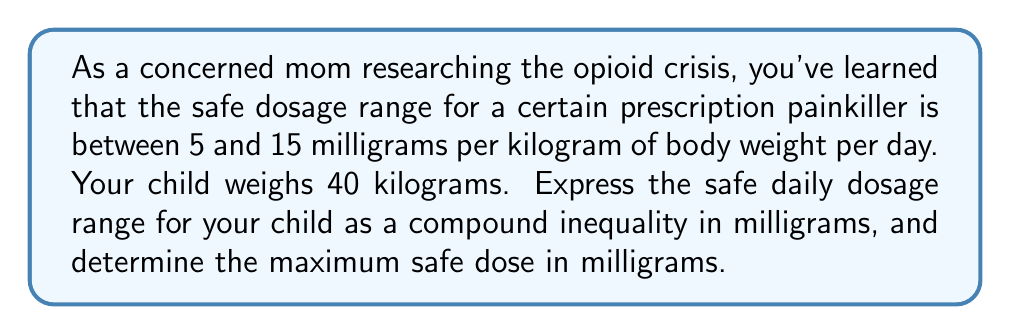Could you help me with this problem? Let's approach this step-by-step:

1) The safe dosage range is 5 to 15 mg per kg of body weight per day.
2) Your child weighs 40 kg.

To find the safe dosage range for your child, we need to multiply both the lower and upper limits by 40:

Lower limit: $5 \times 40 = 200$ mg
Upper limit: $15 \times 40 = 600$ mg

We can express this as a compound inequality:

$$200 \leq x \leq 600$$

Where $x$ represents the daily dose in milligrams.

To determine the maximum safe dose, we simply use the upper limit of this range, which is 600 mg.

This problem illustrates the importance of weight-based dosing in medication safety, particularly for potent drugs like opioids. It's crucial to stay within this range to avoid potential overdose while still providing effective pain relief.
Answer: Compound inequality: $$200 \leq x \leq 600$$ (where $x$ is the daily dose in mg)
Maximum safe dose: 600 mg 